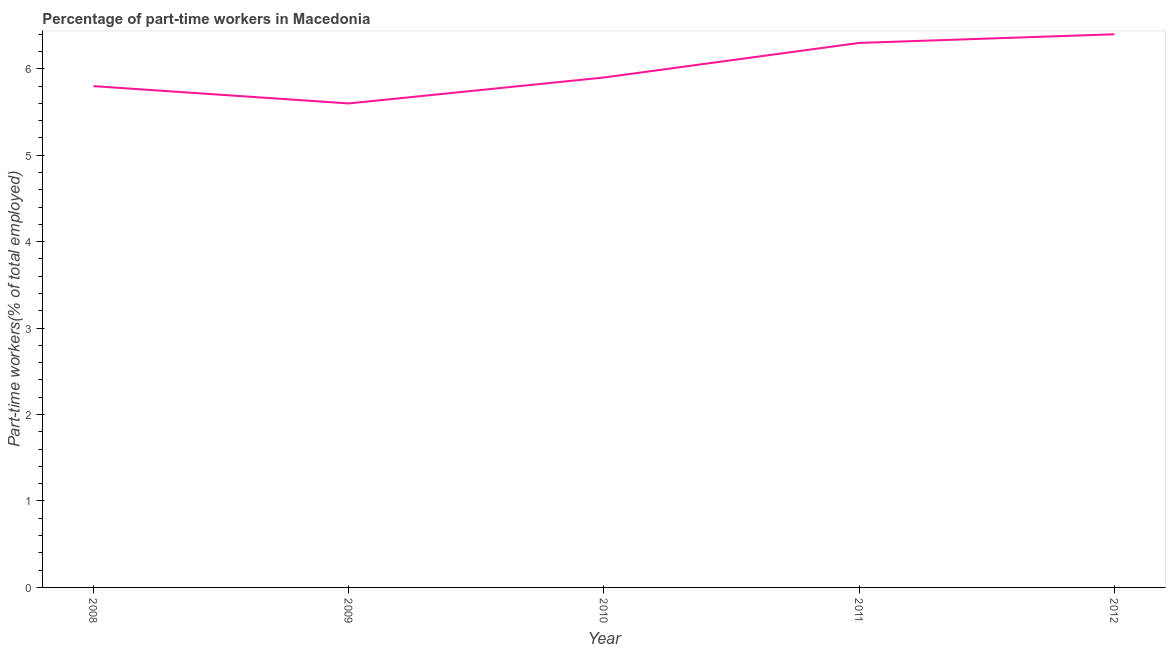What is the percentage of part-time workers in 2012?
Your answer should be very brief. 6.4. Across all years, what is the maximum percentage of part-time workers?
Offer a terse response. 6.4. Across all years, what is the minimum percentage of part-time workers?
Provide a succinct answer. 5.6. In which year was the percentage of part-time workers maximum?
Your answer should be very brief. 2012. In which year was the percentage of part-time workers minimum?
Provide a short and direct response. 2009. What is the sum of the percentage of part-time workers?
Keep it short and to the point. 30. What is the difference between the percentage of part-time workers in 2010 and 2012?
Make the answer very short. -0.5. What is the average percentage of part-time workers per year?
Your response must be concise. 6. What is the median percentage of part-time workers?
Provide a succinct answer. 5.9. In how many years, is the percentage of part-time workers greater than 3.6 %?
Provide a short and direct response. 5. Do a majority of the years between 2011 and 2008 (inclusive) have percentage of part-time workers greater than 2 %?
Give a very brief answer. Yes. What is the ratio of the percentage of part-time workers in 2008 to that in 2010?
Offer a terse response. 0.98. Is the difference between the percentage of part-time workers in 2008 and 2010 greater than the difference between any two years?
Offer a very short reply. No. What is the difference between the highest and the second highest percentage of part-time workers?
Give a very brief answer. 0.1. What is the difference between the highest and the lowest percentage of part-time workers?
Your answer should be compact. 0.8. How many years are there in the graph?
Keep it short and to the point. 5. What is the title of the graph?
Give a very brief answer. Percentage of part-time workers in Macedonia. What is the label or title of the X-axis?
Offer a very short reply. Year. What is the label or title of the Y-axis?
Give a very brief answer. Part-time workers(% of total employed). What is the Part-time workers(% of total employed) of 2008?
Keep it short and to the point. 5.8. What is the Part-time workers(% of total employed) in 2009?
Your answer should be very brief. 5.6. What is the Part-time workers(% of total employed) of 2010?
Provide a short and direct response. 5.9. What is the Part-time workers(% of total employed) of 2011?
Make the answer very short. 6.3. What is the Part-time workers(% of total employed) in 2012?
Ensure brevity in your answer.  6.4. What is the difference between the Part-time workers(% of total employed) in 2008 and 2010?
Keep it short and to the point. -0.1. What is the difference between the Part-time workers(% of total employed) in 2009 and 2010?
Make the answer very short. -0.3. What is the difference between the Part-time workers(% of total employed) in 2010 and 2012?
Provide a succinct answer. -0.5. What is the difference between the Part-time workers(% of total employed) in 2011 and 2012?
Offer a terse response. -0.1. What is the ratio of the Part-time workers(% of total employed) in 2008 to that in 2009?
Make the answer very short. 1.04. What is the ratio of the Part-time workers(% of total employed) in 2008 to that in 2010?
Make the answer very short. 0.98. What is the ratio of the Part-time workers(% of total employed) in 2008 to that in 2011?
Provide a short and direct response. 0.92. What is the ratio of the Part-time workers(% of total employed) in 2008 to that in 2012?
Offer a terse response. 0.91. What is the ratio of the Part-time workers(% of total employed) in 2009 to that in 2010?
Give a very brief answer. 0.95. What is the ratio of the Part-time workers(% of total employed) in 2009 to that in 2011?
Keep it short and to the point. 0.89. What is the ratio of the Part-time workers(% of total employed) in 2010 to that in 2011?
Provide a succinct answer. 0.94. What is the ratio of the Part-time workers(% of total employed) in 2010 to that in 2012?
Provide a succinct answer. 0.92. 